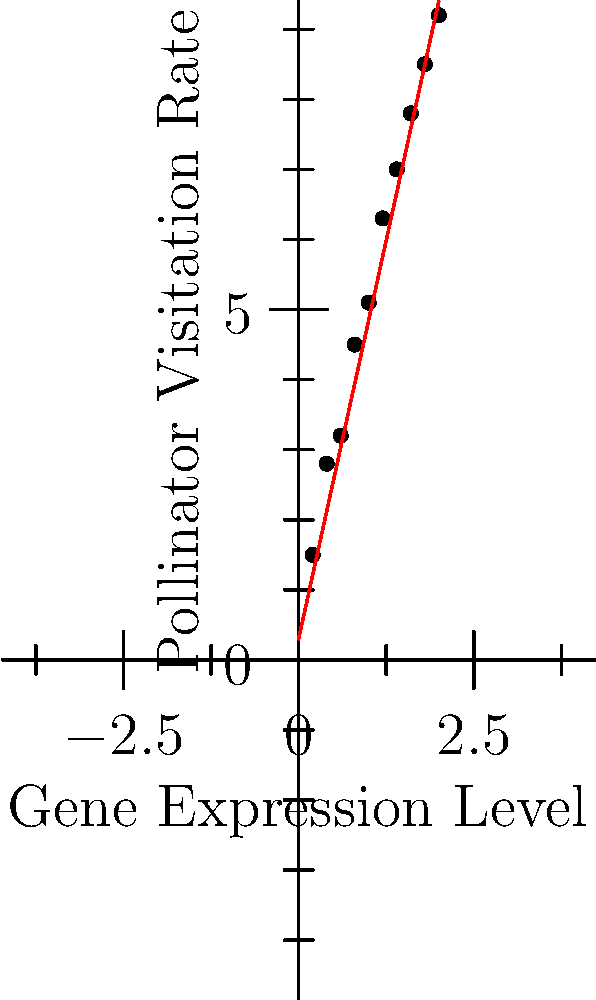Based on the scatter plot showing the relationship between gene expression levels and pollinator visitation rates, what is the approximate slope of the best-fit line, and what does this indicate about the correlation between these two variables? To determine the slope and correlation from the scatter plot:

1. Observe the general trend of the data points: They show a clear upward trend from left to right.

2. Look at the best-fit line (red line): It runs through the middle of the data points, representing the overall trend.

3. Calculate the slope of the best-fit line:
   - Choose two points on the line: (0, 0.3) and (2, 9.4)
   - Use the slope formula: $m = \frac{y_2 - y_1}{x_2 - x_1} = \frac{9.4 - 0.3}{2 - 0} = \frac{9.1}{2} = 4.55$

4. Interpret the slope:
   - The positive slope (approximately 4.55) indicates a positive correlation.
   - For every 1-unit increase in gene expression level, there's an average increase of about 4.55 units in pollinator visitation rate.

5. Assess the strength of the correlation:
   - The data points closely follow the best-fit line, suggesting a strong positive correlation.

Therefore, the slope of approximately 4.55 indicates a strong positive correlation between gene expression levels and pollinator visitation rates. As gene expression increases, pollinator visitation rates tend to increase proportionally.
Answer: Slope ≈ 4.55; strong positive correlation 